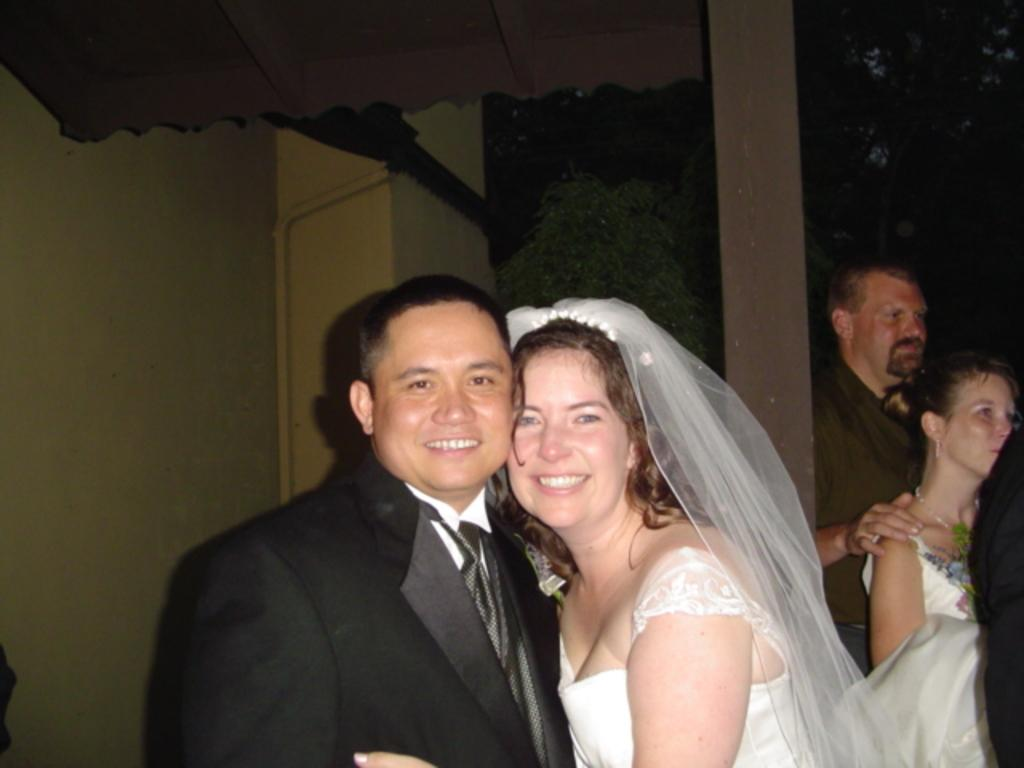Who are the main subjects in the image? There is a bride and a groom in the image. What is the emotional state of the bride and groom? The bride and groom are smiling in the image. Who are the bride and groom looking at? The bride and groom are looking at someone in the image. Are there any other people present in the image? Yes, there are two people standing behind the bride and groom. What type of water can be seen flowing in the background of the image? There is no water visible in the background of the image. What sense is being stimulated by the verse written on the wall? There is no verse written on the wall in the image. 